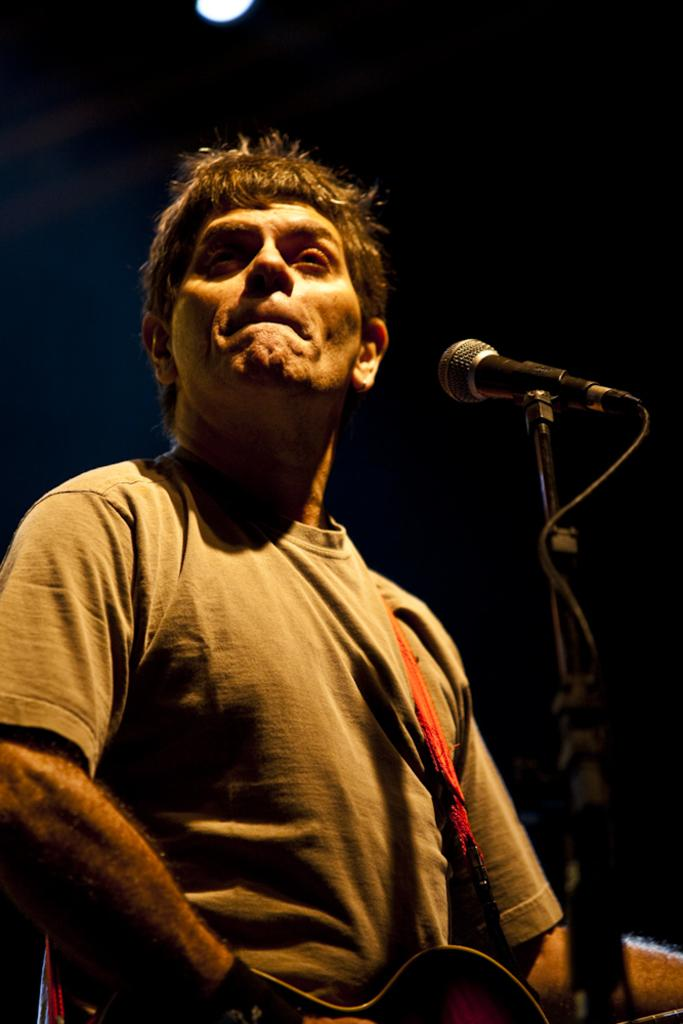Who is the main subject in the image? There is a man in the image. What is the man doing in the image? The man is standing in the image. What object is the man holding in his hand? The man is holding a guitar in his hand. What device is in front of the man? There is a microphone in front of the man. What can be seen at the top of the image? There is a light at the top of the image. What is the plot of the story unfolding in the image? There is no story or plot depicted in the image; it simply shows a man standing with a guitar and a microphone. Can you tell me how the stranger in the image is related to the man? There is no stranger present in the image; it only features the man with a guitar and a microphone. 